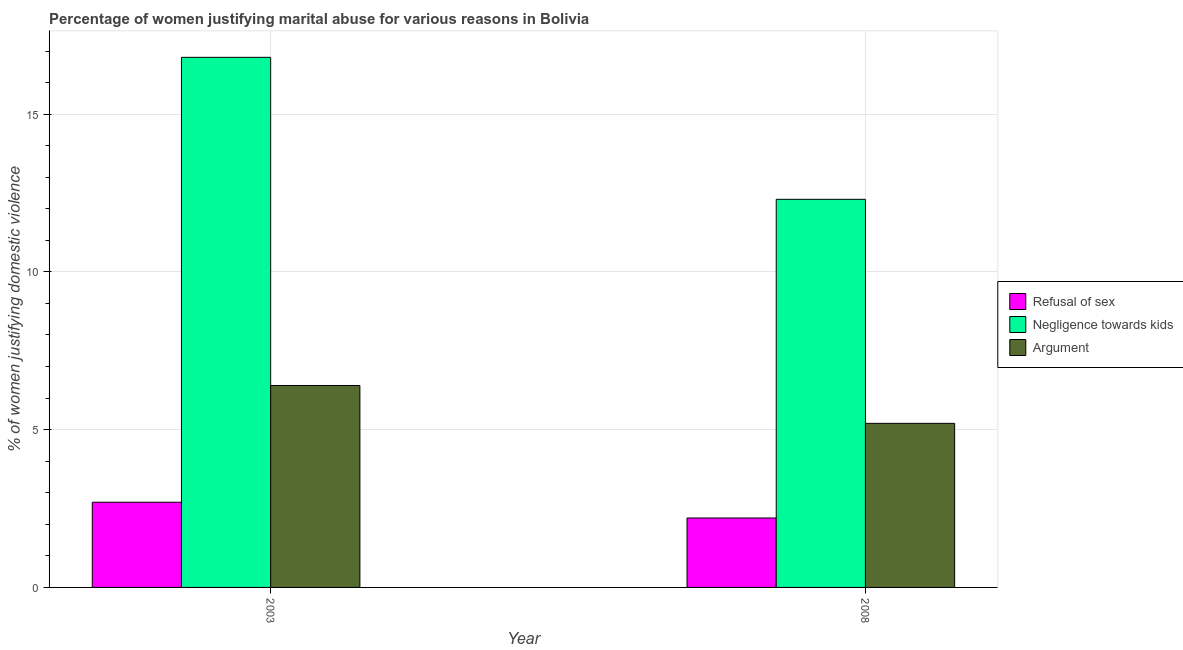How many different coloured bars are there?
Offer a very short reply. 3. Are the number of bars per tick equal to the number of legend labels?
Offer a terse response. Yes. How many bars are there on the 1st tick from the left?
Your answer should be very brief. 3. How many bars are there on the 2nd tick from the right?
Provide a short and direct response. 3. What is the label of the 1st group of bars from the left?
Offer a very short reply. 2003. What is the percentage of women justifying domestic violence due to refusal of sex in 2003?
Make the answer very short. 2.7. Across all years, what is the maximum percentage of women justifying domestic violence due to refusal of sex?
Your answer should be compact. 2.7. Across all years, what is the minimum percentage of women justifying domestic violence due to negligence towards kids?
Your answer should be compact. 12.3. In which year was the percentage of women justifying domestic violence due to refusal of sex maximum?
Give a very brief answer. 2003. What is the total percentage of women justifying domestic violence due to negligence towards kids in the graph?
Your answer should be very brief. 29.1. What is the difference between the percentage of women justifying domestic violence due to arguments in 2003 and that in 2008?
Keep it short and to the point. 1.2. What is the average percentage of women justifying domestic violence due to negligence towards kids per year?
Your response must be concise. 14.55. In how many years, is the percentage of women justifying domestic violence due to refusal of sex greater than 8 %?
Make the answer very short. 0. What is the ratio of the percentage of women justifying domestic violence due to arguments in 2003 to that in 2008?
Offer a very short reply. 1.23. Is the percentage of women justifying domestic violence due to refusal of sex in 2003 less than that in 2008?
Keep it short and to the point. No. What does the 1st bar from the left in 2008 represents?
Give a very brief answer. Refusal of sex. What does the 2nd bar from the right in 2003 represents?
Offer a terse response. Negligence towards kids. Are all the bars in the graph horizontal?
Make the answer very short. No. How many years are there in the graph?
Provide a succinct answer. 2. Does the graph contain grids?
Keep it short and to the point. Yes. How are the legend labels stacked?
Your answer should be very brief. Vertical. What is the title of the graph?
Ensure brevity in your answer.  Percentage of women justifying marital abuse for various reasons in Bolivia. What is the label or title of the Y-axis?
Keep it short and to the point. % of women justifying domestic violence. What is the % of women justifying domestic violence in Argument in 2003?
Offer a very short reply. 6.4. Across all years, what is the maximum % of women justifying domestic violence in Negligence towards kids?
Your response must be concise. 16.8. Across all years, what is the maximum % of women justifying domestic violence in Argument?
Your answer should be compact. 6.4. Across all years, what is the minimum % of women justifying domestic violence in Argument?
Your answer should be compact. 5.2. What is the total % of women justifying domestic violence in Negligence towards kids in the graph?
Keep it short and to the point. 29.1. What is the difference between the % of women justifying domestic violence in Refusal of sex in 2003 and that in 2008?
Make the answer very short. 0.5. What is the difference between the % of women justifying domestic violence in Refusal of sex in 2003 and the % of women justifying domestic violence in Negligence towards kids in 2008?
Your response must be concise. -9.6. What is the difference between the % of women justifying domestic violence of Refusal of sex in 2003 and the % of women justifying domestic violence of Argument in 2008?
Your answer should be very brief. -2.5. What is the average % of women justifying domestic violence in Refusal of sex per year?
Keep it short and to the point. 2.45. What is the average % of women justifying domestic violence of Negligence towards kids per year?
Your answer should be compact. 14.55. In the year 2003, what is the difference between the % of women justifying domestic violence in Refusal of sex and % of women justifying domestic violence in Negligence towards kids?
Keep it short and to the point. -14.1. In the year 2008, what is the difference between the % of women justifying domestic violence of Negligence towards kids and % of women justifying domestic violence of Argument?
Offer a very short reply. 7.1. What is the ratio of the % of women justifying domestic violence in Refusal of sex in 2003 to that in 2008?
Your answer should be compact. 1.23. What is the ratio of the % of women justifying domestic violence of Negligence towards kids in 2003 to that in 2008?
Offer a very short reply. 1.37. What is the ratio of the % of women justifying domestic violence of Argument in 2003 to that in 2008?
Offer a very short reply. 1.23. What is the difference between the highest and the second highest % of women justifying domestic violence of Argument?
Keep it short and to the point. 1.2. What is the difference between the highest and the lowest % of women justifying domestic violence of Negligence towards kids?
Offer a very short reply. 4.5. 